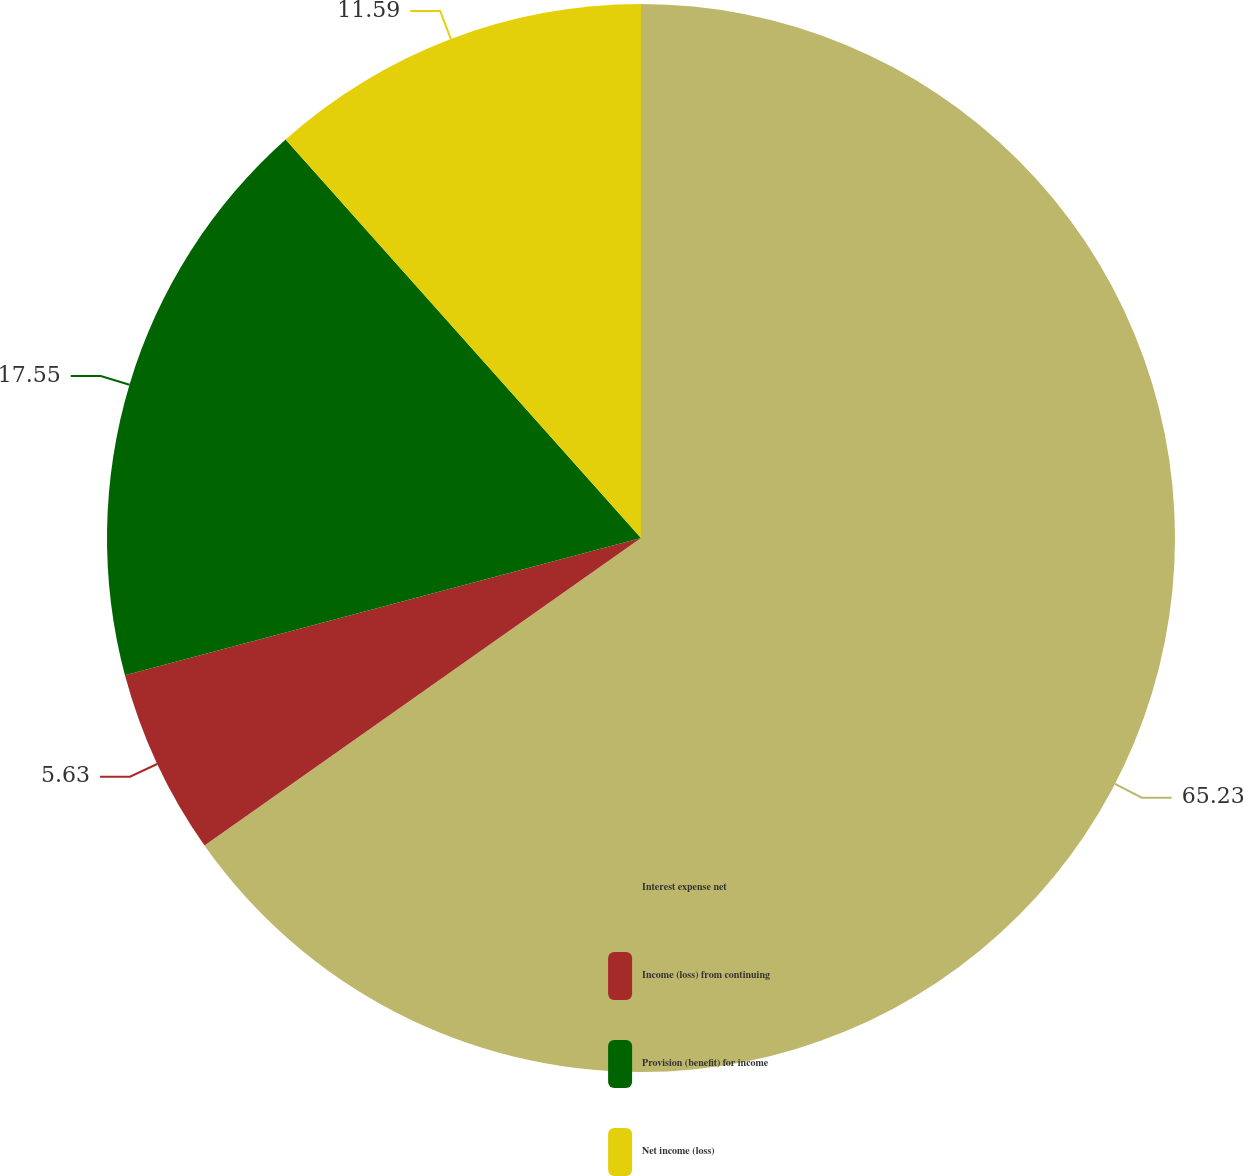Convert chart. <chart><loc_0><loc_0><loc_500><loc_500><pie_chart><fcel>Interest expense net<fcel>Income (loss) from continuing<fcel>Provision (benefit) for income<fcel>Net income (loss)<nl><fcel>65.23%<fcel>5.63%<fcel>17.55%<fcel>11.59%<nl></chart> 